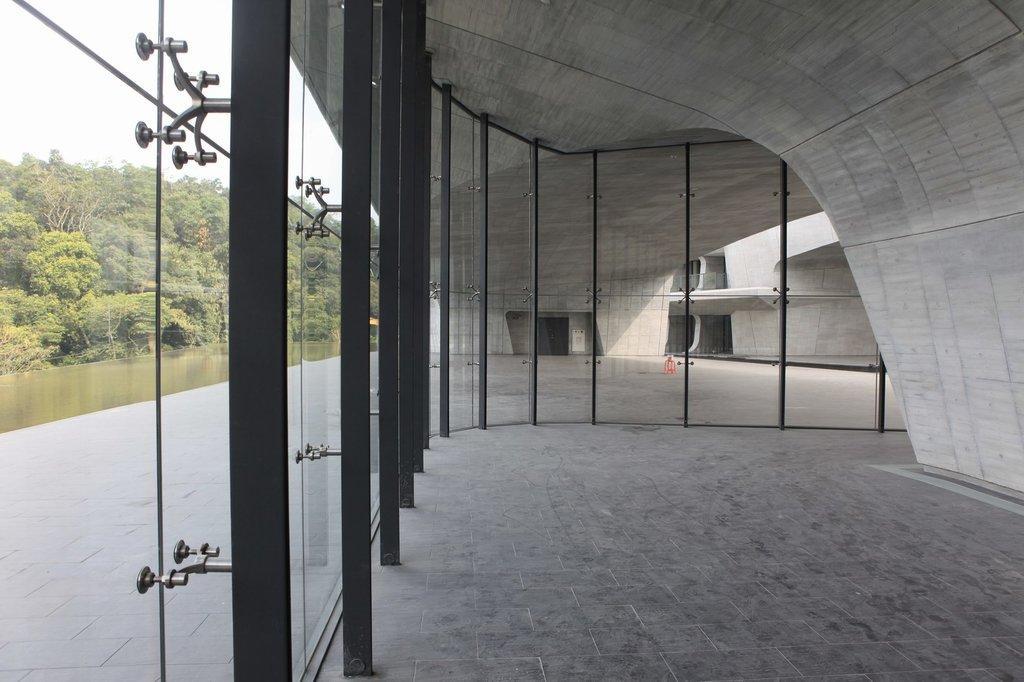Please provide a concise description of this image. In this image we can see glass windows, metal poles and the wall. On the left side of the image we can see a group of trees and the sky. 